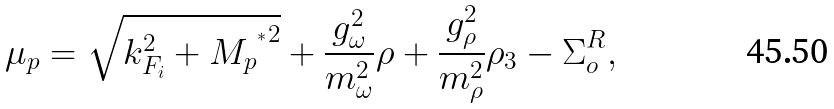<formula> <loc_0><loc_0><loc_500><loc_500>\mu _ { p } = \sqrt { k _ { F _ { i } } ^ { 2 } + { { M _ { p } } ^ { ^ { * } } } ^ { 2 } } + \frac { g _ { \omega } ^ { 2 } } { m _ { \omega } ^ { 2 } } \rho + \frac { g _ { \rho } ^ { 2 } } { m _ { \rho } ^ { 2 } } \rho _ { 3 } - \Sigma _ { o } ^ { R } ,</formula> 